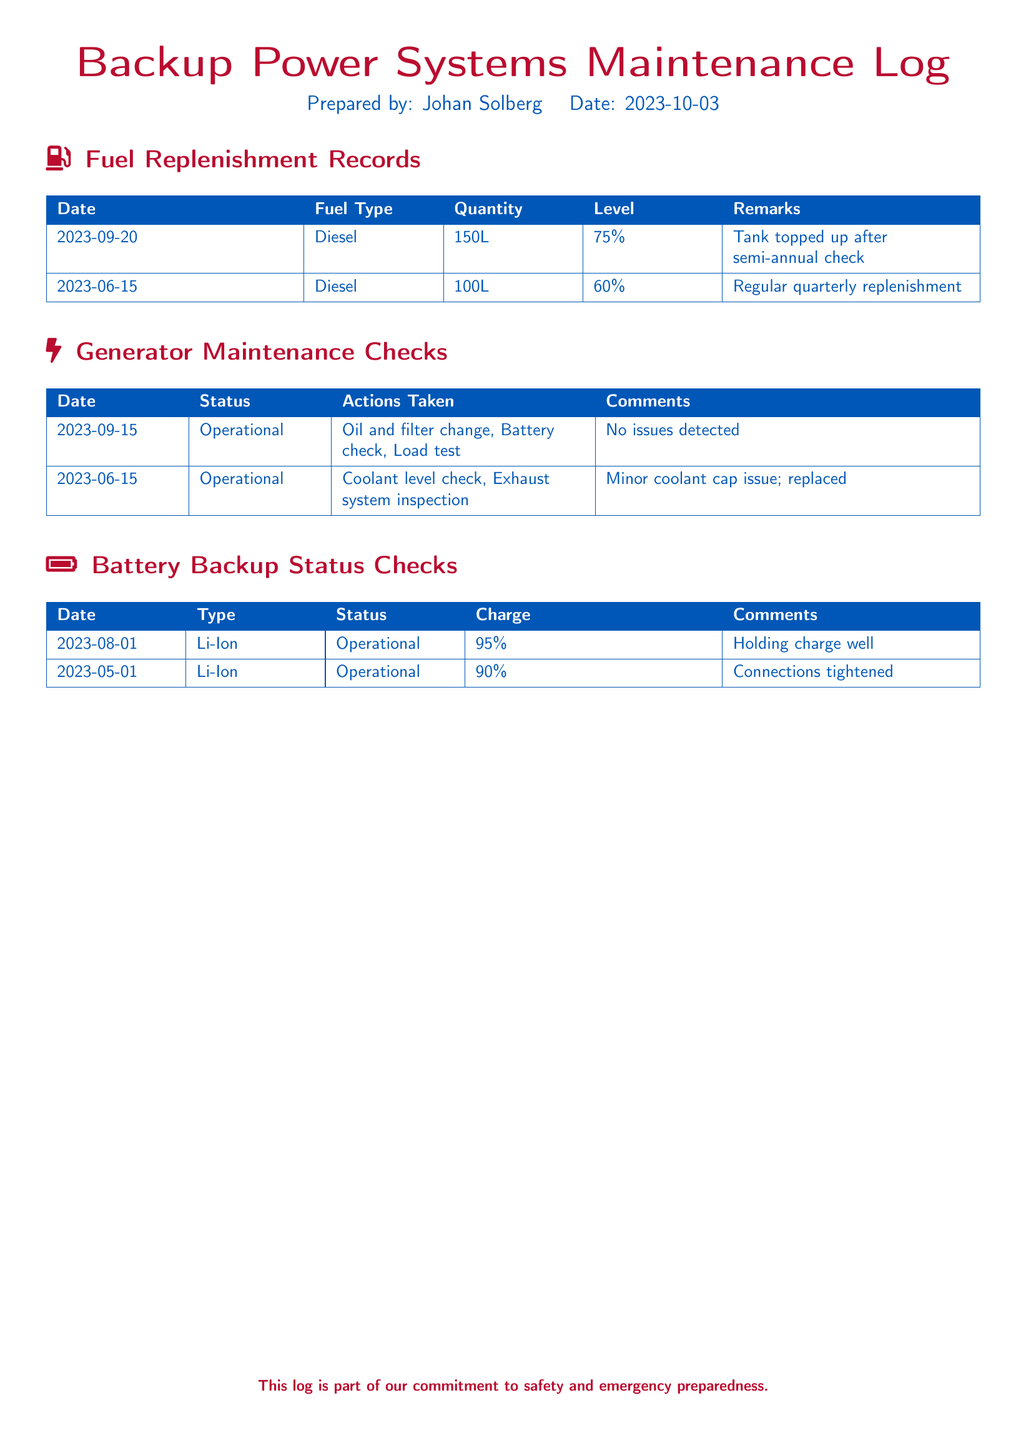What date was the last fuel replenishment recorded? The last fuel replenishment recorded is dated September 20, 2023.
Answer: September 20, 2023 What type of fuel is recorded in the log? The fuel type recorded in the log is Diesel.
Answer: Diesel What was the quantity of diesel added on June 15, 2023? The quantity of diesel added on June 15, 2023, was 100 liters.
Answer: 100L What was the status of the generator during the maintenance check on September 15, 2023? The status of the generator during the maintenance check on September 15, 2023, was Operational.
Answer: Operational How many percent was the charge of the battery backup on August 1, 2023? The charge of the battery backup on August 1, 2023, was 95 percent.
Answer: 95% What action was taken during the generator maintenance check on June 15, 2023? One of the actions taken was a Coolant level check.
Answer: Coolant level check Which battery type is mentioned in the log? The battery type mentioned in the log is Li-Ion.
Answer: Li-Ion What issues were detected during the generator check on September 15, 2023? No issues were detected during the generator check on September 15, 2023.
Answer: No issues detected What fuel level was reached after the replenishment on September 20, 2023? After the replenishment, the fuel level reached 75 percent.
Answer: 75% 